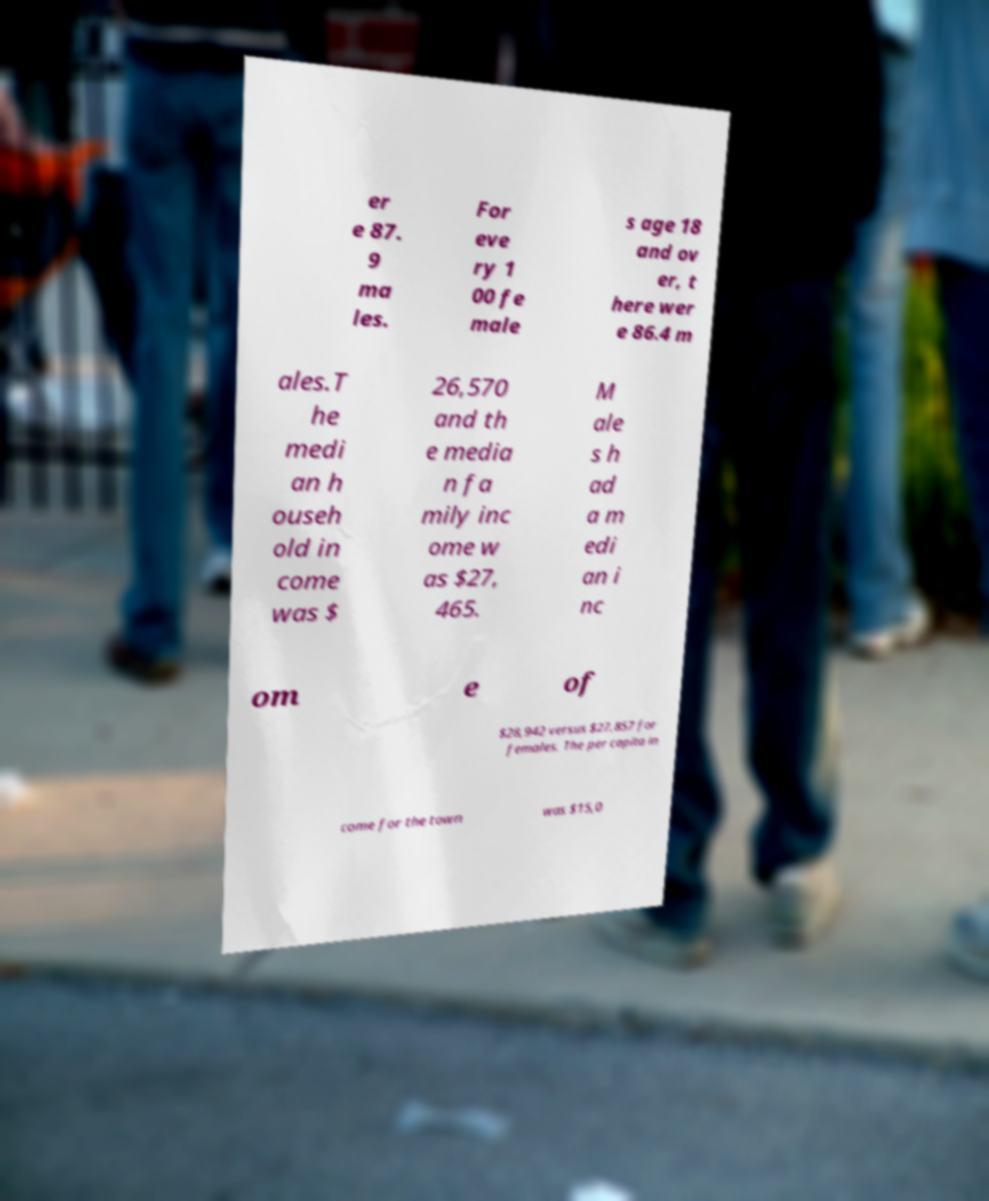Could you assist in decoding the text presented in this image and type it out clearly? er e 87. 9 ma les. For eve ry 1 00 fe male s age 18 and ov er, t here wer e 86.4 m ales.T he medi an h ouseh old in come was $ 26,570 and th e media n fa mily inc ome w as $27, 465. M ale s h ad a m edi an i nc om e of $28,942 versus $27,857 for females. The per capita in come for the town was $15,0 